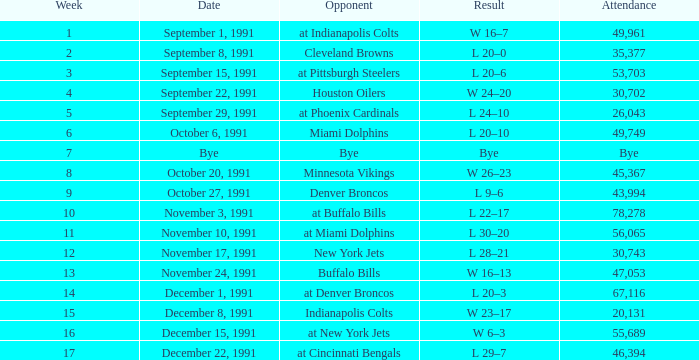What transpired in the contest on december 22, 1991? L 29–7. 